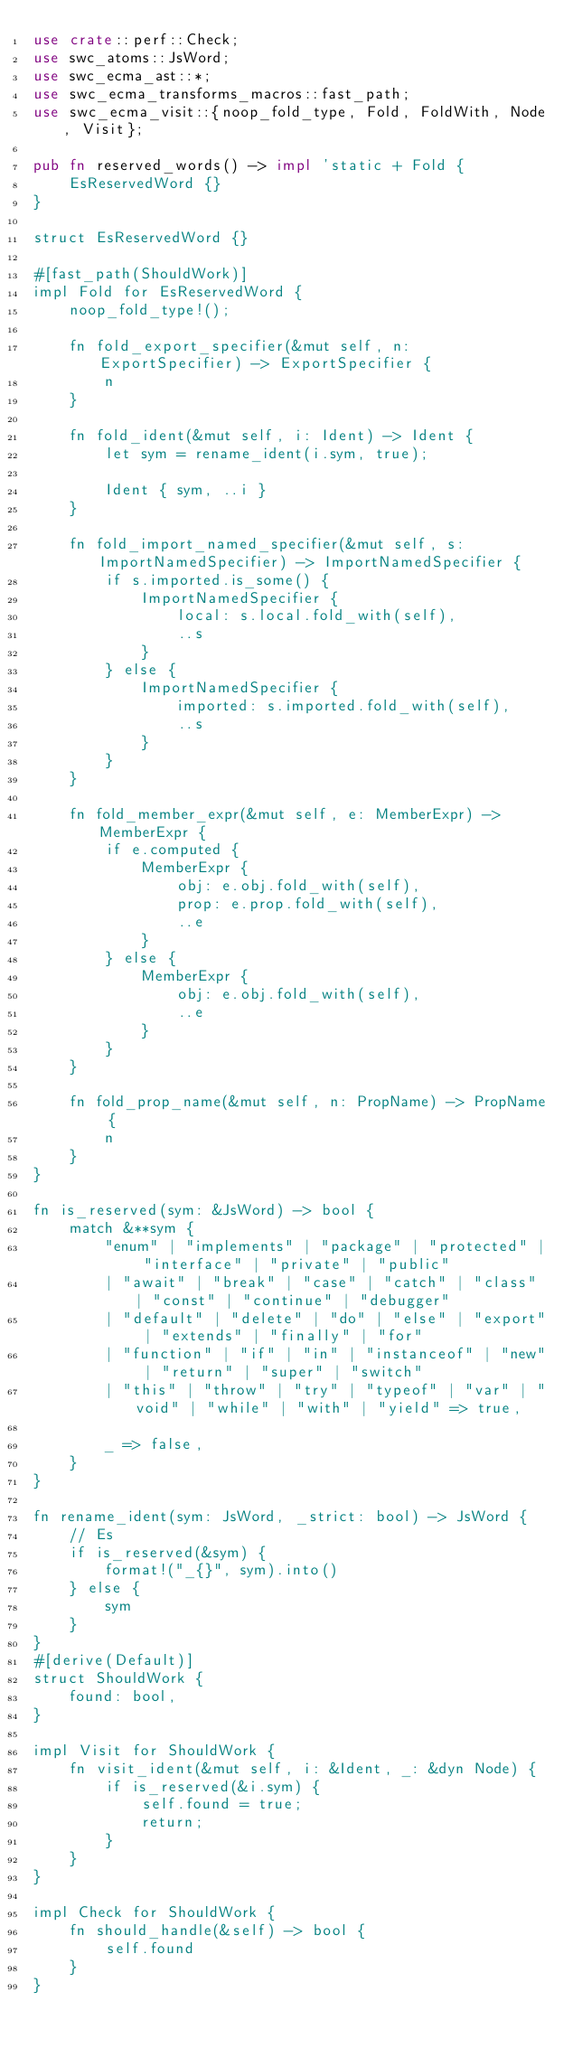<code> <loc_0><loc_0><loc_500><loc_500><_Rust_>use crate::perf::Check;
use swc_atoms::JsWord;
use swc_ecma_ast::*;
use swc_ecma_transforms_macros::fast_path;
use swc_ecma_visit::{noop_fold_type, Fold, FoldWith, Node, Visit};

pub fn reserved_words() -> impl 'static + Fold {
    EsReservedWord {}
}

struct EsReservedWord {}

#[fast_path(ShouldWork)]
impl Fold for EsReservedWord {
    noop_fold_type!();

    fn fold_export_specifier(&mut self, n: ExportSpecifier) -> ExportSpecifier {
        n
    }

    fn fold_ident(&mut self, i: Ident) -> Ident {
        let sym = rename_ident(i.sym, true);

        Ident { sym, ..i }
    }

    fn fold_import_named_specifier(&mut self, s: ImportNamedSpecifier) -> ImportNamedSpecifier {
        if s.imported.is_some() {
            ImportNamedSpecifier {
                local: s.local.fold_with(self),
                ..s
            }
        } else {
            ImportNamedSpecifier {
                imported: s.imported.fold_with(self),
                ..s
            }
        }
    }

    fn fold_member_expr(&mut self, e: MemberExpr) -> MemberExpr {
        if e.computed {
            MemberExpr {
                obj: e.obj.fold_with(self),
                prop: e.prop.fold_with(self),
                ..e
            }
        } else {
            MemberExpr {
                obj: e.obj.fold_with(self),
                ..e
            }
        }
    }

    fn fold_prop_name(&mut self, n: PropName) -> PropName {
        n
    }
}

fn is_reserved(sym: &JsWord) -> bool {
    match &**sym {
        "enum" | "implements" | "package" | "protected" | "interface" | "private" | "public"
        | "await" | "break" | "case" | "catch" | "class" | "const" | "continue" | "debugger"
        | "default" | "delete" | "do" | "else" | "export" | "extends" | "finally" | "for"
        | "function" | "if" | "in" | "instanceof" | "new" | "return" | "super" | "switch"
        | "this" | "throw" | "try" | "typeof" | "var" | "void" | "while" | "with" | "yield" => true,

        _ => false,
    }
}

fn rename_ident(sym: JsWord, _strict: bool) -> JsWord {
    // Es
    if is_reserved(&sym) {
        format!("_{}", sym).into()
    } else {
        sym
    }
}
#[derive(Default)]
struct ShouldWork {
    found: bool,
}

impl Visit for ShouldWork {
    fn visit_ident(&mut self, i: &Ident, _: &dyn Node) {
        if is_reserved(&i.sym) {
            self.found = true;
            return;
        }
    }
}

impl Check for ShouldWork {
    fn should_handle(&self) -> bool {
        self.found
    }
}
</code> 